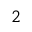<formula> <loc_0><loc_0><loc_500><loc_500>^ { 2 }</formula> 